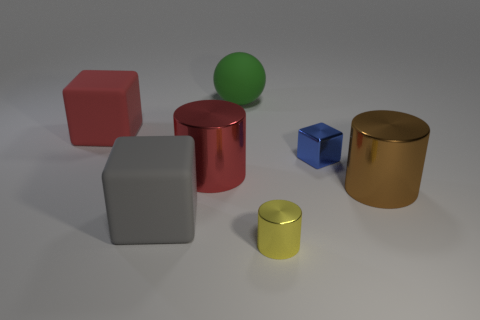How many other objects are there of the same shape as the red rubber thing?
Your response must be concise. 2. Do the green thing and the yellow metal thing have the same size?
Your answer should be compact. No. Is the number of brown shiny cylinders that are on the left side of the red cylinder greater than the number of red objects that are right of the yellow object?
Offer a very short reply. No. How many other objects are the same size as the red rubber object?
Provide a short and direct response. 4. Are there more big cubes to the left of the gray object than large green shiny cylinders?
Give a very brief answer. Yes. What shape is the large red thing that is behind the large cylinder that is to the left of the yellow cylinder?
Ensure brevity in your answer.  Cube. Are there more big green spheres than tiny objects?
Make the answer very short. No. How many big things are both on the left side of the large green ball and in front of the large red matte block?
Ensure brevity in your answer.  2. There is a large shiny cylinder that is left of the green thing; how many cylinders are in front of it?
Offer a very short reply. 2. What number of objects are either small shiny things behind the big gray thing or small metal objects on the left side of the small blue metal block?
Your answer should be compact. 2. 